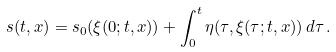<formula> <loc_0><loc_0><loc_500><loc_500>s ( t , x ) = s _ { 0 } ( \xi ( 0 ; t , x ) ) + \int _ { 0 } ^ { t } \eta ( \tau , \xi ( \tau ; t , x ) ) \, d \tau \, .</formula> 